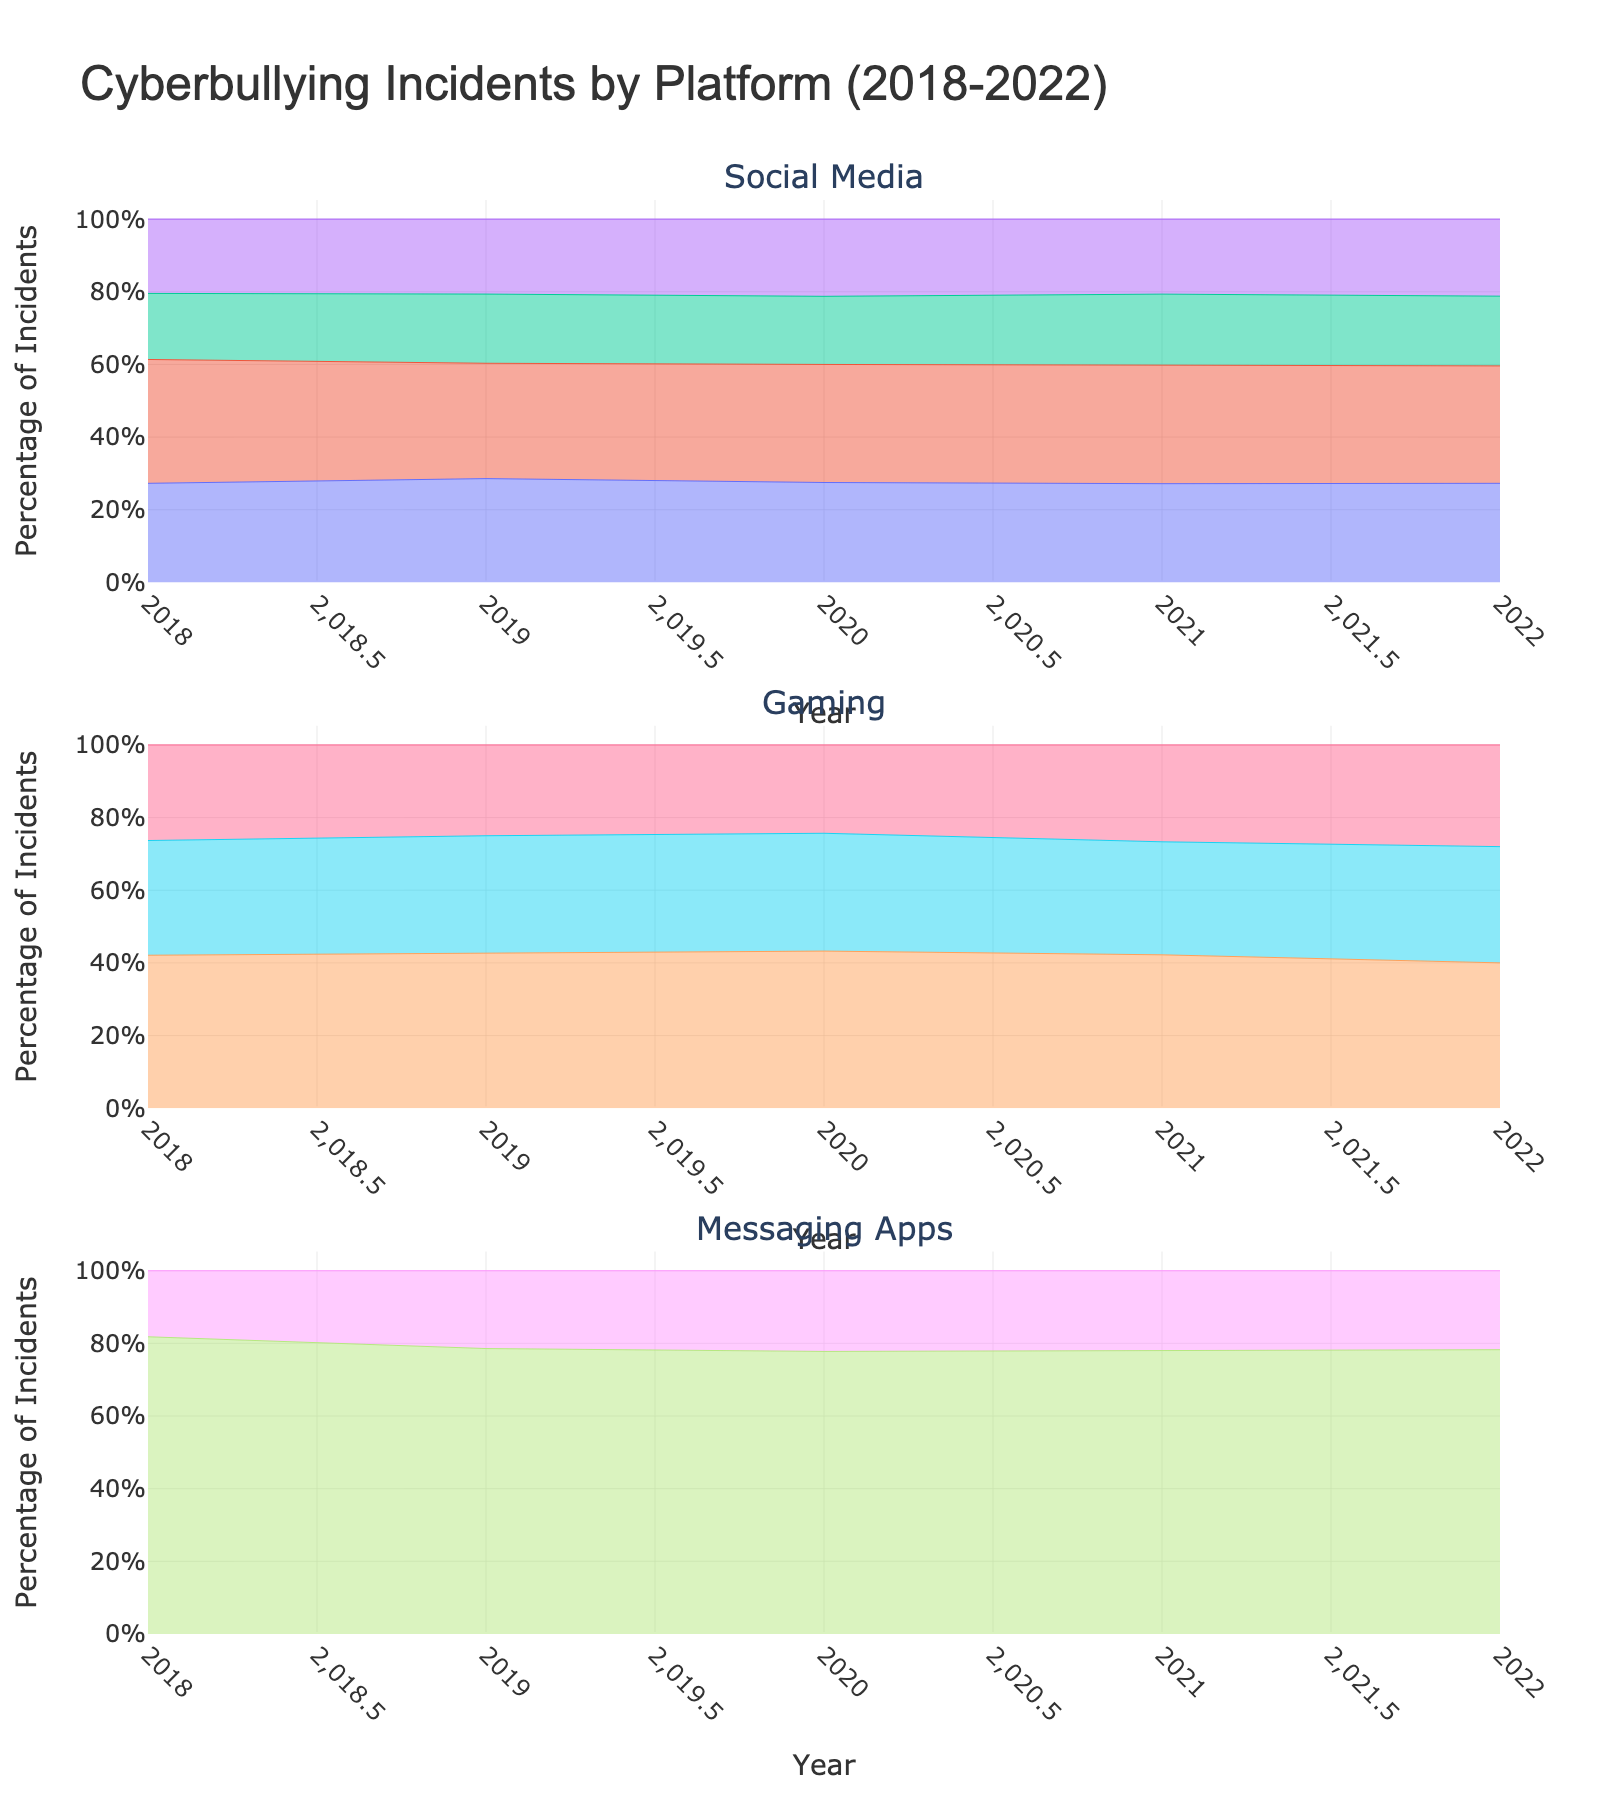What is the title of the figure? The title is displayed at the top of the figure and indicates the overall topic it covers.
Answer: "Cyberbullying Incidents by Platform (2018-2022)" Which platform had the highest number of reported incidents in 2018? Look at the data points for 2018 across all platforms and observe the highest value in the different subplots representing Social Media, Gaming, and Messaging Apps. The highest incident count can be identified by the tallest peak in the corresponding area chart.
Answer: Instagram How have cyberbullying incidents on the WhatsApp messaging app changed over the years? Examine the area chart for Messaging Apps and observe the trendline for WhatsApp from 2018 to 2022. Look for increases or decreases in the height of the area representing WhatsApp over those years.
Answer: Increased Which social media platform saw the greatest increase in cyberbullying incidents from 2018 to 2022? Compare the initial and final values for each social media platform, observing the difference in the height of their respective areas in the chart. The platform with the steepest increase in height over the years shows the greatest increase.
Answer: Instagram What percentage of reported incidents on gaming platforms came from Fortnite in 2020? Focus on the gaming platform subplot for the year 2020. Observe the height of the area representing Fortnite in comparison to the total height of the area chart for all gaming platforms in that year; the percentage is the height of Fortnite's area divided by the total height in 2020.
Answer: Around 50% In which year did Snapchat see a rapid increase in incidents? Examine the trendline in the Social Media subplot specifically for Snapchat. Determine the time period where there is a noticeable and rapid increase in the height of its corresponding area.
Answer: 2019 to 2020 Which platform had the least number of reported cyberbullying incidents in 2021? Compare the lowest points on the area charts across all subplots for the year 2021. The lowest peak identifies the platform with the least incidents.
Answer: Kik How does the trend in cyberbullying incidents on Instagram compare to Facebook from 2018-2022? Review the Social Media subplot and trace the trendlines for Instagram and Facebook. Compare their slopes and values over the five-year period to assess similarities and differences in the trend patterns.
Answer: Instagram shows a higher rate of increase than Facebook What is the average number of reported incidents for Minecraft from 2018-2022? Add the yearly incidents for Minecraft from 2018 through 2022 and divide by the number of years (5) to get the average.
Answer: (300+450+600+700+800)/5 = 570 